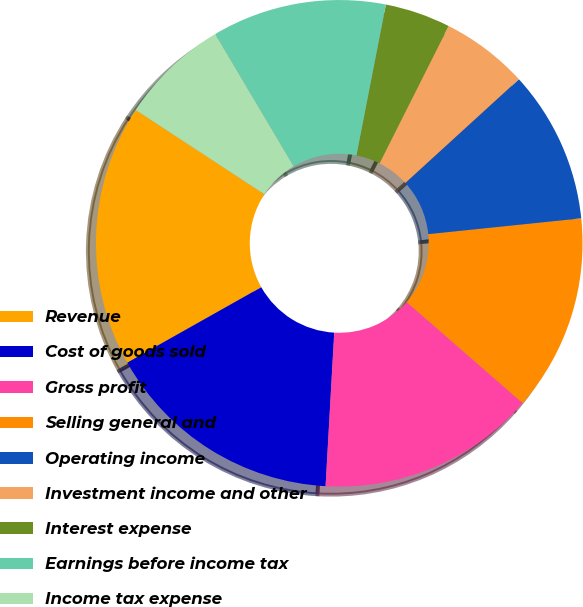Convert chart. <chart><loc_0><loc_0><loc_500><loc_500><pie_chart><fcel>Revenue<fcel>Cost of goods sold<fcel>Gross profit<fcel>Selling general and<fcel>Operating income<fcel>Investment income and other<fcel>Interest expense<fcel>Earnings before income tax<fcel>Income tax expense<fcel>Minority interests in earnings<nl><fcel>17.39%<fcel>15.94%<fcel>14.49%<fcel>13.04%<fcel>10.14%<fcel>5.8%<fcel>4.35%<fcel>11.59%<fcel>7.25%<fcel>0.0%<nl></chart> 